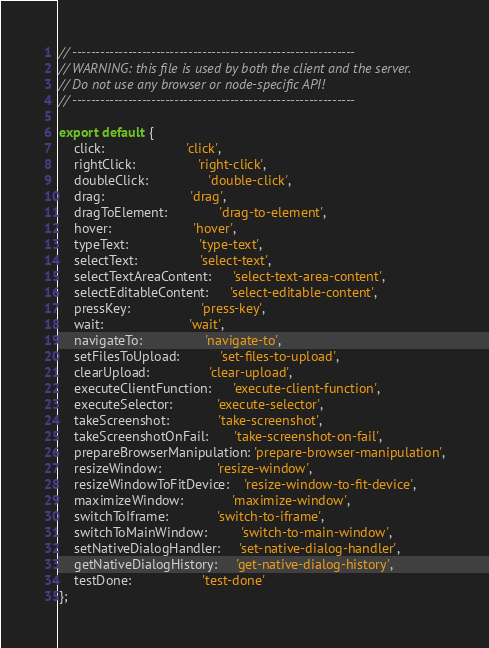Convert code to text. <code><loc_0><loc_0><loc_500><loc_500><_JavaScript_>// -------------------------------------------------------------
// WARNING: this file is used by both the client and the server.
// Do not use any browser or node-specific API!
// -------------------------------------------------------------

export default {
    click:                      'click',
    rightClick:                 'right-click',
    doubleClick:                'double-click',
    drag:                       'drag',
    dragToElement:              'drag-to-element',
    hover:                      'hover',
    typeText:                   'type-text',
    selectText:                 'select-text',
    selectTextAreaContent:      'select-text-area-content',
    selectEditableContent:      'select-editable-content',
    pressKey:                   'press-key',
    wait:                       'wait',
    navigateTo:                 'navigate-to',
    setFilesToUpload:           'set-files-to-upload',
    clearUpload:                'clear-upload',
    executeClientFunction:      'execute-client-function',
    executeSelector:            'execute-selector',
    takeScreenshot:             'take-screenshot',
    takeScreenshotOnFail:       'take-screenshot-on-fail',
    prepareBrowserManipulation: 'prepare-browser-manipulation',
    resizeWindow:               'resize-window',
    resizeWindowToFitDevice:    'resize-window-to-fit-device',
    maximizeWindow:             'maximize-window',
    switchToIframe:             'switch-to-iframe',
    switchToMainWindow:         'switch-to-main-window',
    setNativeDialogHandler:     'set-native-dialog-handler',
    getNativeDialogHistory:     'get-native-dialog-history',
    testDone:                   'test-done'
};
</code> 